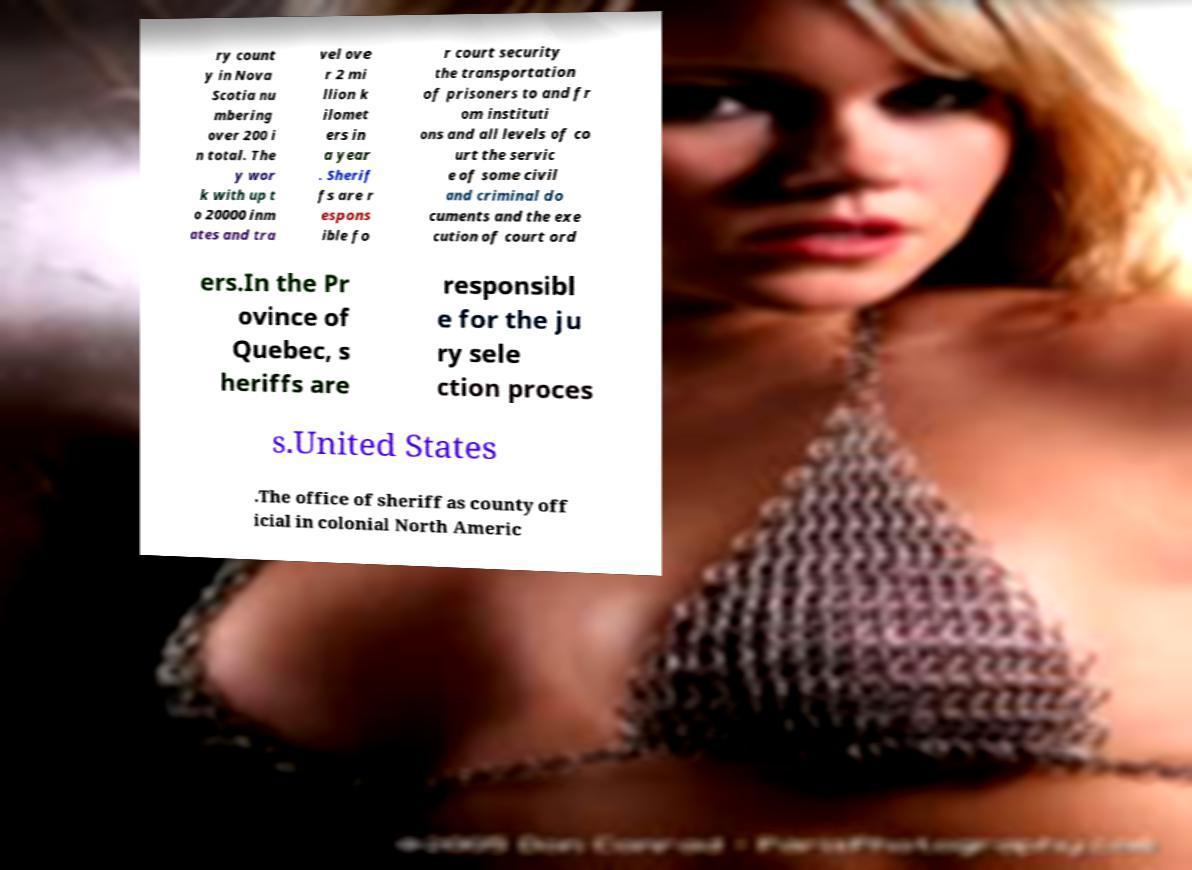Can you read and provide the text displayed in the image?This photo seems to have some interesting text. Can you extract and type it out for me? ry count y in Nova Scotia nu mbering over 200 i n total. The y wor k with up t o 20000 inm ates and tra vel ove r 2 mi llion k ilomet ers in a year . Sherif fs are r espons ible fo r court security the transportation of prisoners to and fr om instituti ons and all levels of co urt the servic e of some civil and criminal do cuments and the exe cution of court ord ers.In the Pr ovince of Quebec, s heriffs are responsibl e for the ju ry sele ction proces s.United States .The office of sheriff as county off icial in colonial North Americ 